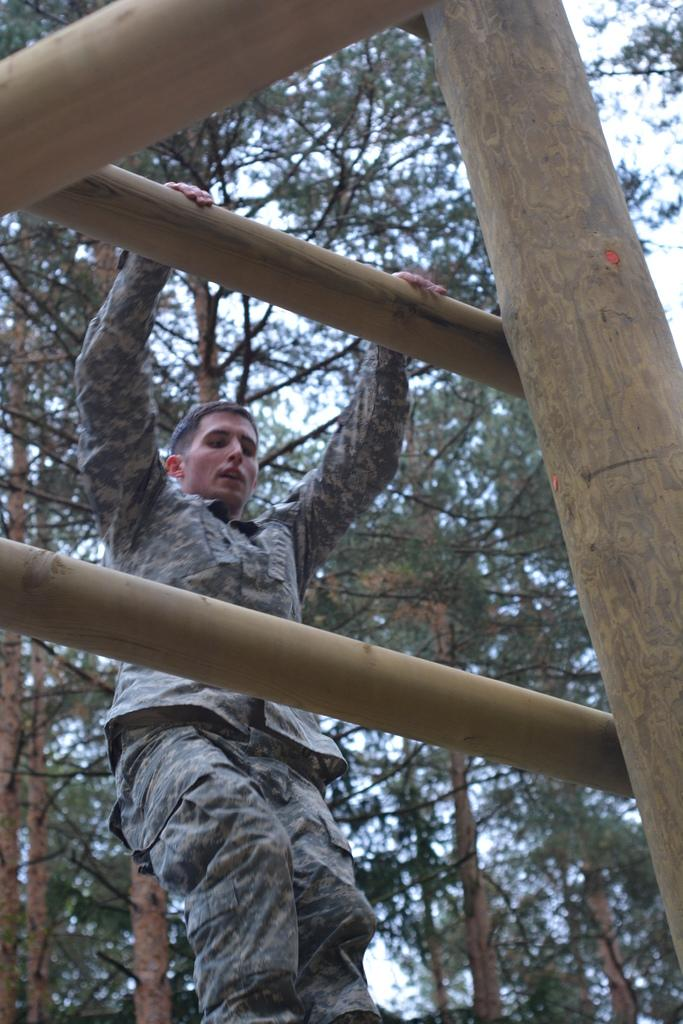Who is present in the image? There is a man in the image. What is the man wearing? The man is wearing a uniform. What can be seen in the distance in the image? There are trees visible in the background of the image. What type of pollution can be seen in the image? There is no pollution visible in the image; it only features a man in a uniform and trees in the background. 